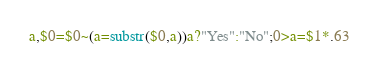Convert code to text. <code><loc_0><loc_0><loc_500><loc_500><_Awk_>a,$0=$0~(a=substr($0,a))a?"Yes":"No";0>a=$1*.63</code> 